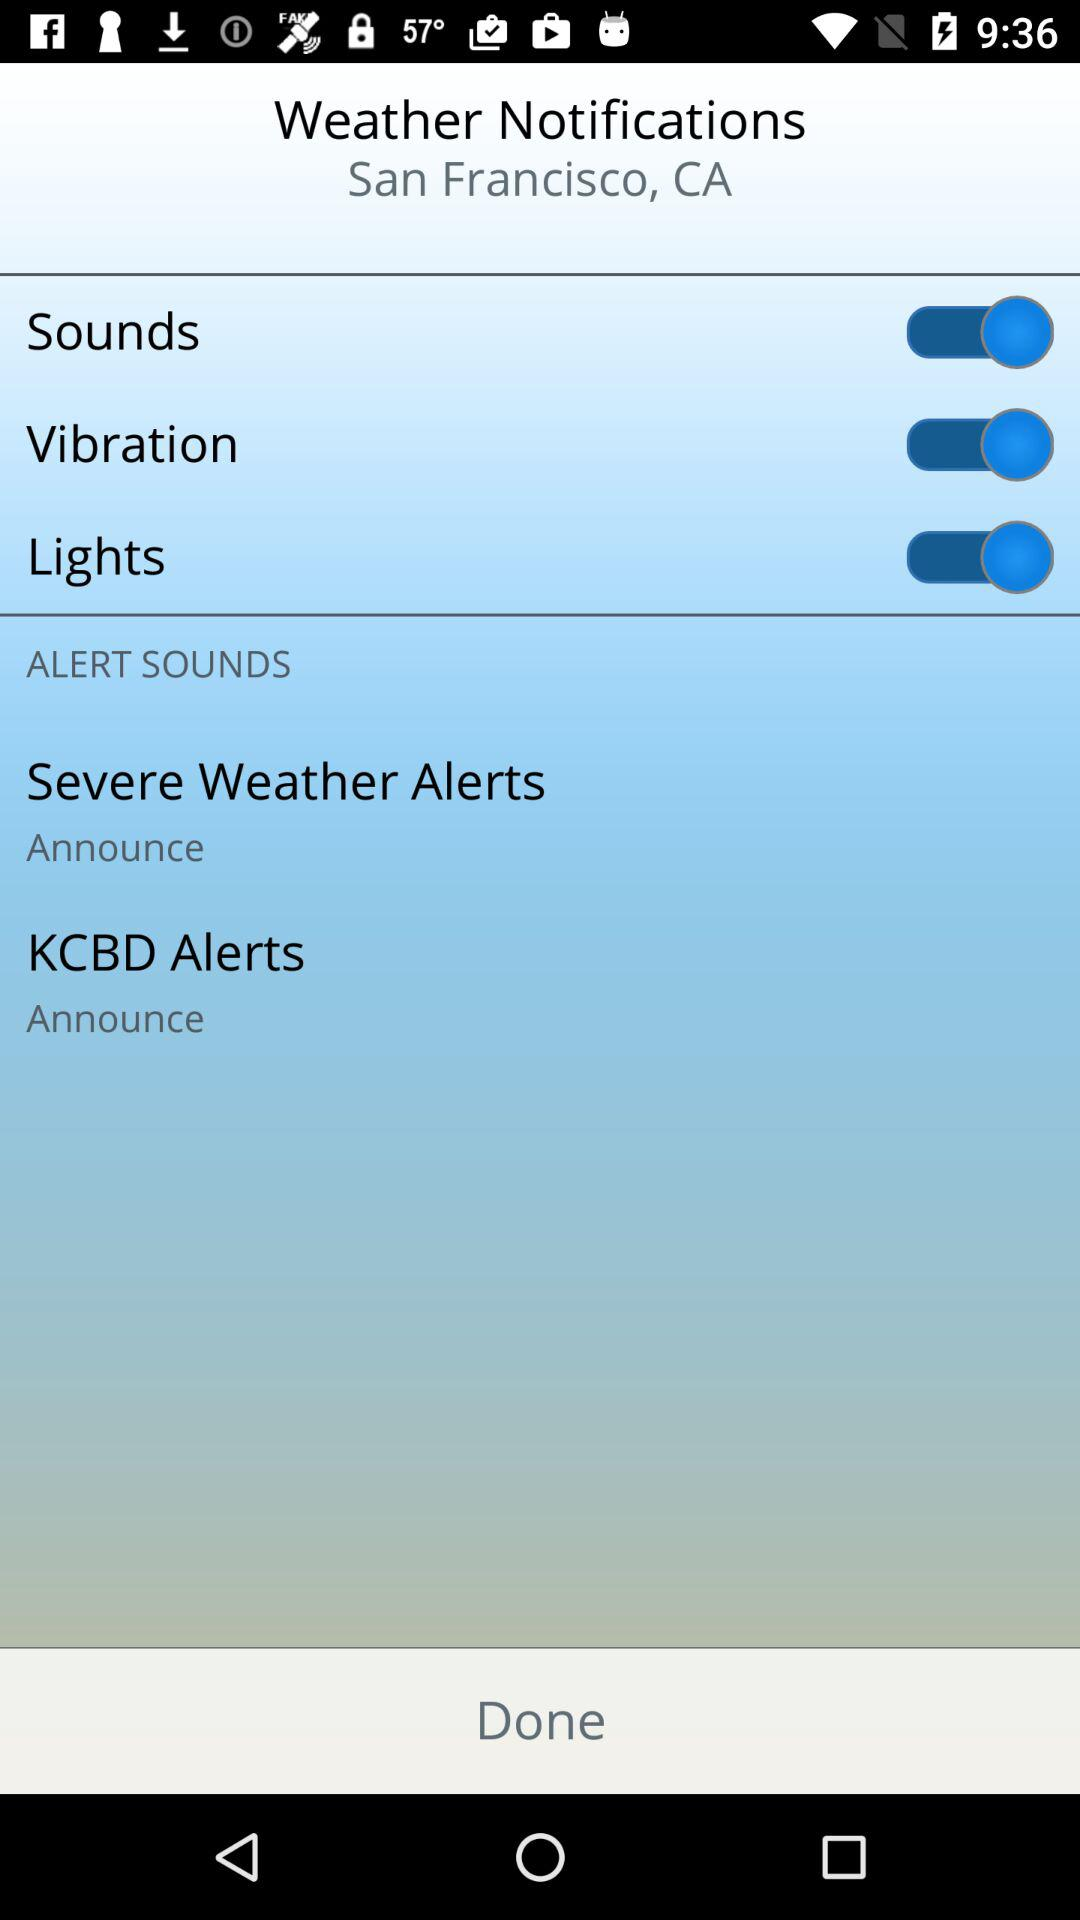What is the setting for KCBD alerts? The setting for KCBD alerts is "Announce". 